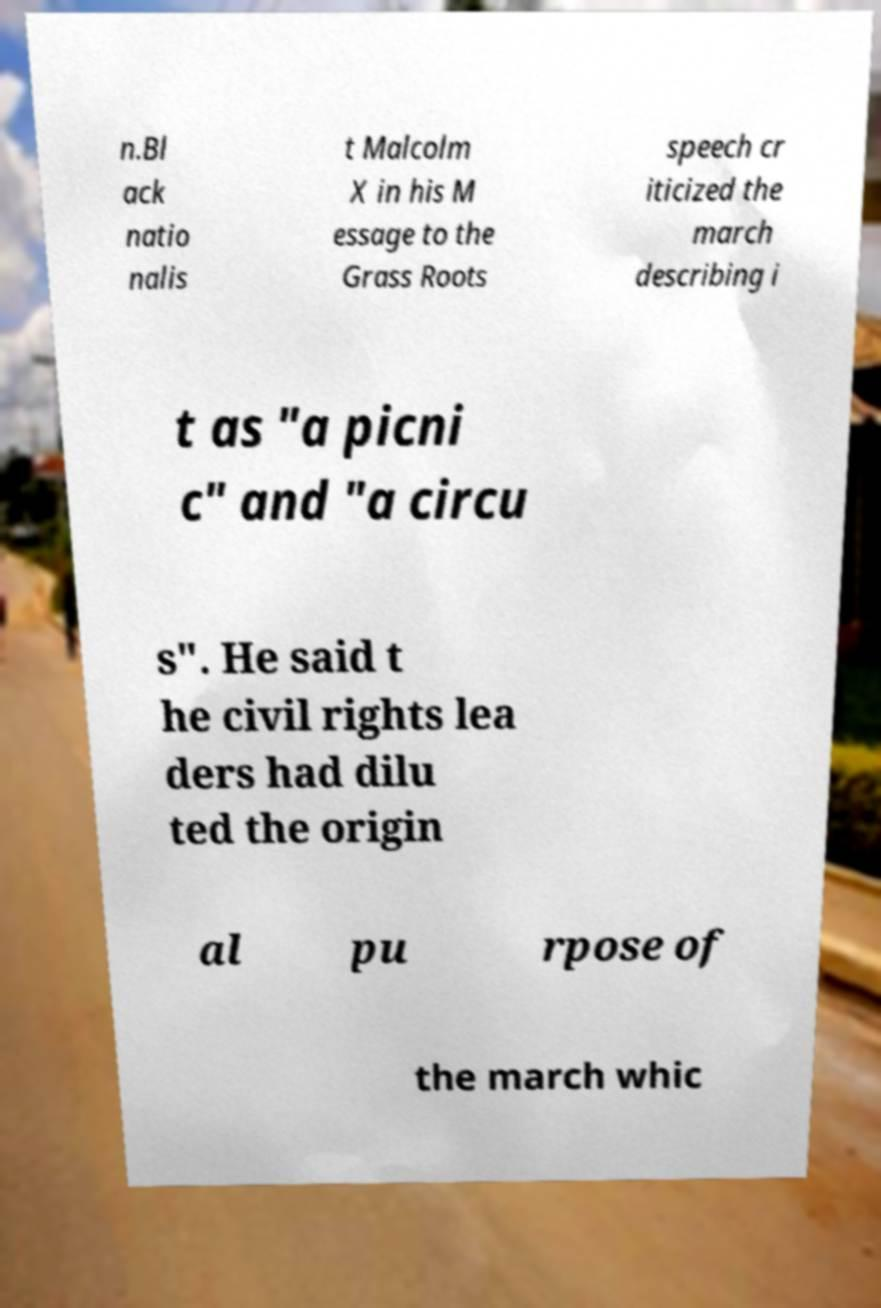Could you assist in decoding the text presented in this image and type it out clearly? n.Bl ack natio nalis t Malcolm X in his M essage to the Grass Roots speech cr iticized the march describing i t as "a picni c" and "a circu s". He said t he civil rights lea ders had dilu ted the origin al pu rpose of the march whic 